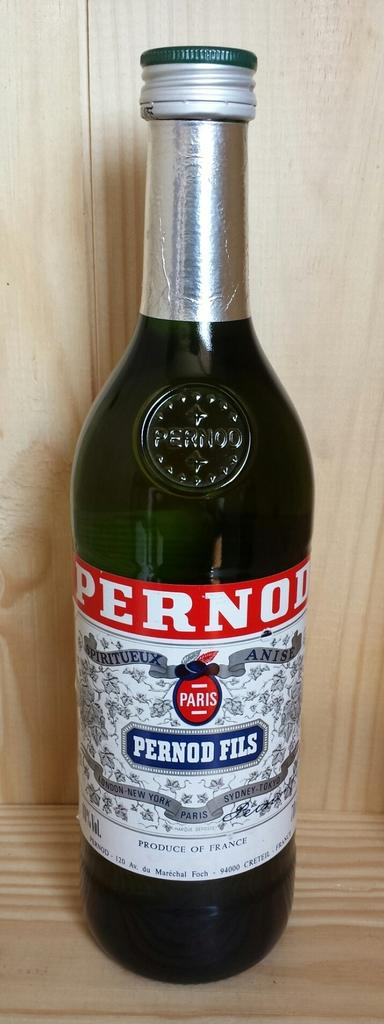Provide a one-sentence caption for the provided image. Bottle of pernod fils wine that is new and unopen. 